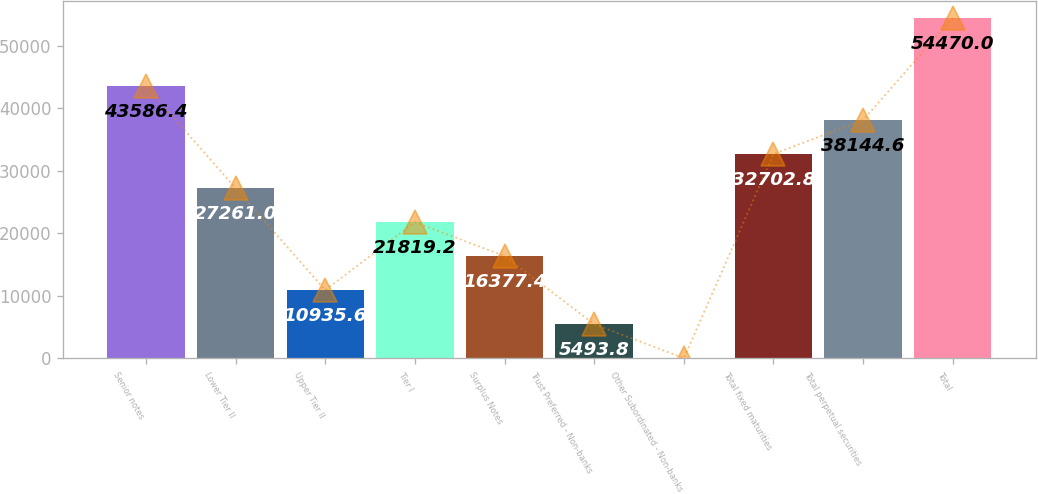<chart> <loc_0><loc_0><loc_500><loc_500><bar_chart><fcel>Senior notes<fcel>Lower Tier II<fcel>Upper Tier II<fcel>Tier I<fcel>Surplus Notes<fcel>Trust Preferred - Non-banks<fcel>Other Subordinated - Non-banks<fcel>Total fixed maturities<fcel>Total perpetual securities<fcel>Total<nl><fcel>43586.4<fcel>27261<fcel>10935.6<fcel>21819.2<fcel>16377.4<fcel>5493.8<fcel>52<fcel>32702.8<fcel>38144.6<fcel>54470<nl></chart> 